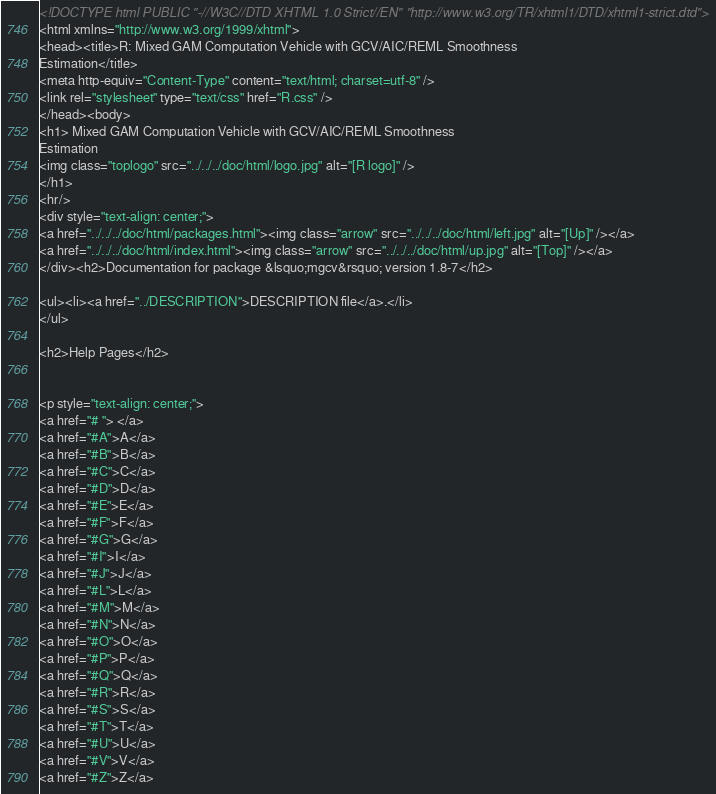<code> <loc_0><loc_0><loc_500><loc_500><_HTML_><!DOCTYPE html PUBLIC "-//W3C//DTD XHTML 1.0 Strict//EN" "http://www.w3.org/TR/xhtml1/DTD/xhtml1-strict.dtd">
<html xmlns="http://www.w3.org/1999/xhtml">
<head><title>R: Mixed GAM Computation Vehicle with GCV/AIC/REML Smoothness
Estimation</title>
<meta http-equiv="Content-Type" content="text/html; charset=utf-8" />
<link rel="stylesheet" type="text/css" href="R.css" />
</head><body>
<h1> Mixed GAM Computation Vehicle with GCV/AIC/REML Smoothness
Estimation
<img class="toplogo" src="../../../doc/html/logo.jpg" alt="[R logo]" />
</h1>
<hr/>
<div style="text-align: center;">
<a href="../../../doc/html/packages.html"><img class="arrow" src="../../../doc/html/left.jpg" alt="[Up]" /></a>
<a href="../../../doc/html/index.html"><img class="arrow" src="../../../doc/html/up.jpg" alt="[Top]" /></a>
</div><h2>Documentation for package &lsquo;mgcv&rsquo; version 1.8-7</h2>

<ul><li><a href="../DESCRIPTION">DESCRIPTION file</a>.</li>
</ul>

<h2>Help Pages</h2>


<p style="text-align: center;">
<a href="# "> </a>
<a href="#A">A</a>
<a href="#B">B</a>
<a href="#C">C</a>
<a href="#D">D</a>
<a href="#E">E</a>
<a href="#F">F</a>
<a href="#G">G</a>
<a href="#I">I</a>
<a href="#J">J</a>
<a href="#L">L</a>
<a href="#M">M</a>
<a href="#N">N</a>
<a href="#O">O</a>
<a href="#P">P</a>
<a href="#Q">Q</a>
<a href="#R">R</a>
<a href="#S">S</a>
<a href="#T">T</a>
<a href="#U">U</a>
<a href="#V">V</a>
<a href="#Z">Z</a></code> 